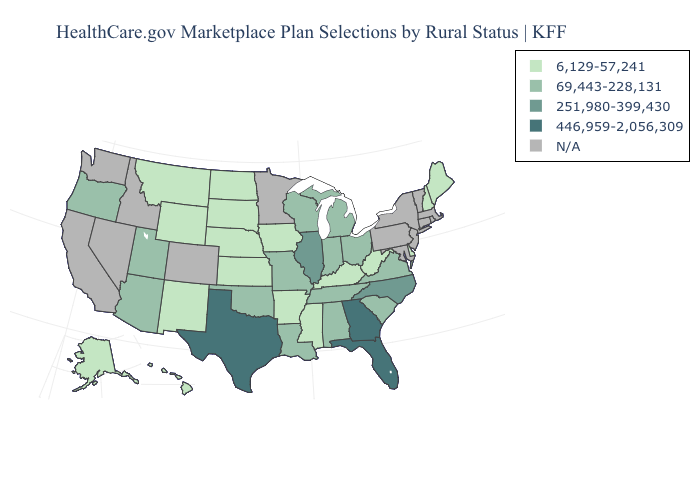What is the value of Oregon?
Quick response, please. 69,443-228,131. Name the states that have a value in the range 251,980-399,430?
Short answer required. Illinois, North Carolina. What is the value of New Mexico?
Give a very brief answer. 6,129-57,241. Does Wyoming have the lowest value in the West?
Quick response, please. Yes. What is the lowest value in the Northeast?
Write a very short answer. 6,129-57,241. Among the states that border Nebraska , which have the lowest value?
Be succinct. Iowa, Kansas, South Dakota, Wyoming. What is the highest value in the MidWest ?
Quick response, please. 251,980-399,430. Which states have the lowest value in the USA?
Write a very short answer. Alaska, Arkansas, Delaware, Hawaii, Iowa, Kansas, Kentucky, Maine, Mississippi, Montana, Nebraska, New Hampshire, New Mexico, North Dakota, South Dakota, West Virginia, Wyoming. What is the value of Arkansas?
Short answer required. 6,129-57,241. What is the value of Ohio?
Keep it brief. 69,443-228,131. Is the legend a continuous bar?
Short answer required. No. 